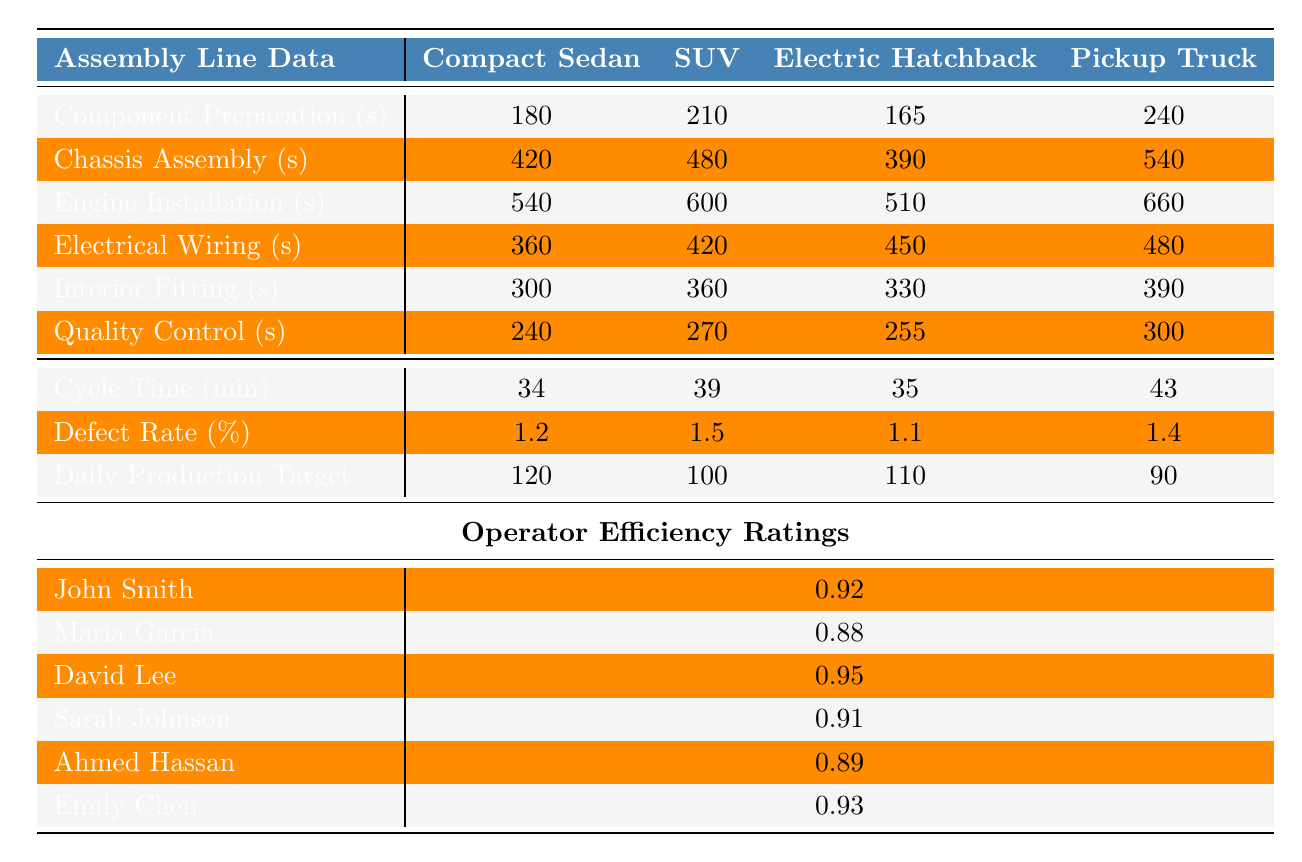What is the cycle time for the Electric Hatchback? The table provides the cycle times for each product model. The row for cycle time specifically shows that it is 35 minutes for the Electric Hatchback.
Answer: 35 minutes Who has the highest efficiency rating among the operators? The table lists the efficiency ratings for each operator. By comparing these values, David Lee has the highest rating at 0.95.
Answer: David Lee What is the total assembly time in seconds for the Chassis Assembly of the Compact Sedan? The table shows that the time measurement for Chassis Assembly of the Compact Sedan is 420 seconds. No additional calculations are needed as it is a direct retrieval.
Answer: 420 seconds Is the defect rate for the Electric Hatchback lower than that for the SUV? The defect rates are listed in the table: Electric Hatchback has a defect rate of 1.1% and SUV has 1.5%. Since 1.1% is less than 1.5%, the statement is true.
Answer: Yes What is the average time in seconds for Quality Control across all product models? The Quality Control times are 240, 270, 255, and 300 seconds for the models. Summing these gives 1065 seconds, and dividing by 4 (the number of models) provides an average of 266.25 seconds.
Answer: 266.25 seconds What is the production target gap between Compact Sedan and Pickup Truck? The daily production targets for Compact Sedan and Pickup Truck are 120 and 90, respectively. The gap can be calculated by subtracting the Pickup Truck target from the Compact Sedan target: 120 - 90 = 30.
Answer: 30 Which assembly station has the longest time for SUV production? The assembly station times for SUV are: Component Preparation (210s), Chassis Assembly (480s), Engine Installation (600s), Electrical Wiring (420s), Interior Fitting (360s), Quality Control (270s). The longest time is Engine Installation at 600 seconds.
Answer: Engine Installation How do the total times for Component Preparation compare between Electric Hatchback and Pickup Truck? The total for Component Preparation is 165 seconds for Electric Hatchback and 240 seconds for Pickup Truck. To compare, 240 seconds (Pickup Truck) is greater than 165 seconds (Electric Hatchback), indicating Pickup Truck requires more time.
Answer: Pickup Truck has longer time Is the average operator efficiency greater than 0.90? The efficiency ratings for all operators are: 0.92, 0.88, 0.95, 0.91, 0.89, and 0.93. Calculating the average gives (0.92 + 0.88 + 0.95 + 0.91 + 0.89 + 0.93) / 6 = 0.9167, which is greater than 0.90.
Answer: Yes Which product model has the lowest defect rate? The defect rates from the table are: Compact Sedan (1.2%), SUV (1.5%), Electric Hatchback (1.1%), and Pickup Truck (1.4%). The lowest defect rate is for the Electric Hatchback at 1.1%.
Answer: Electric Hatchback 